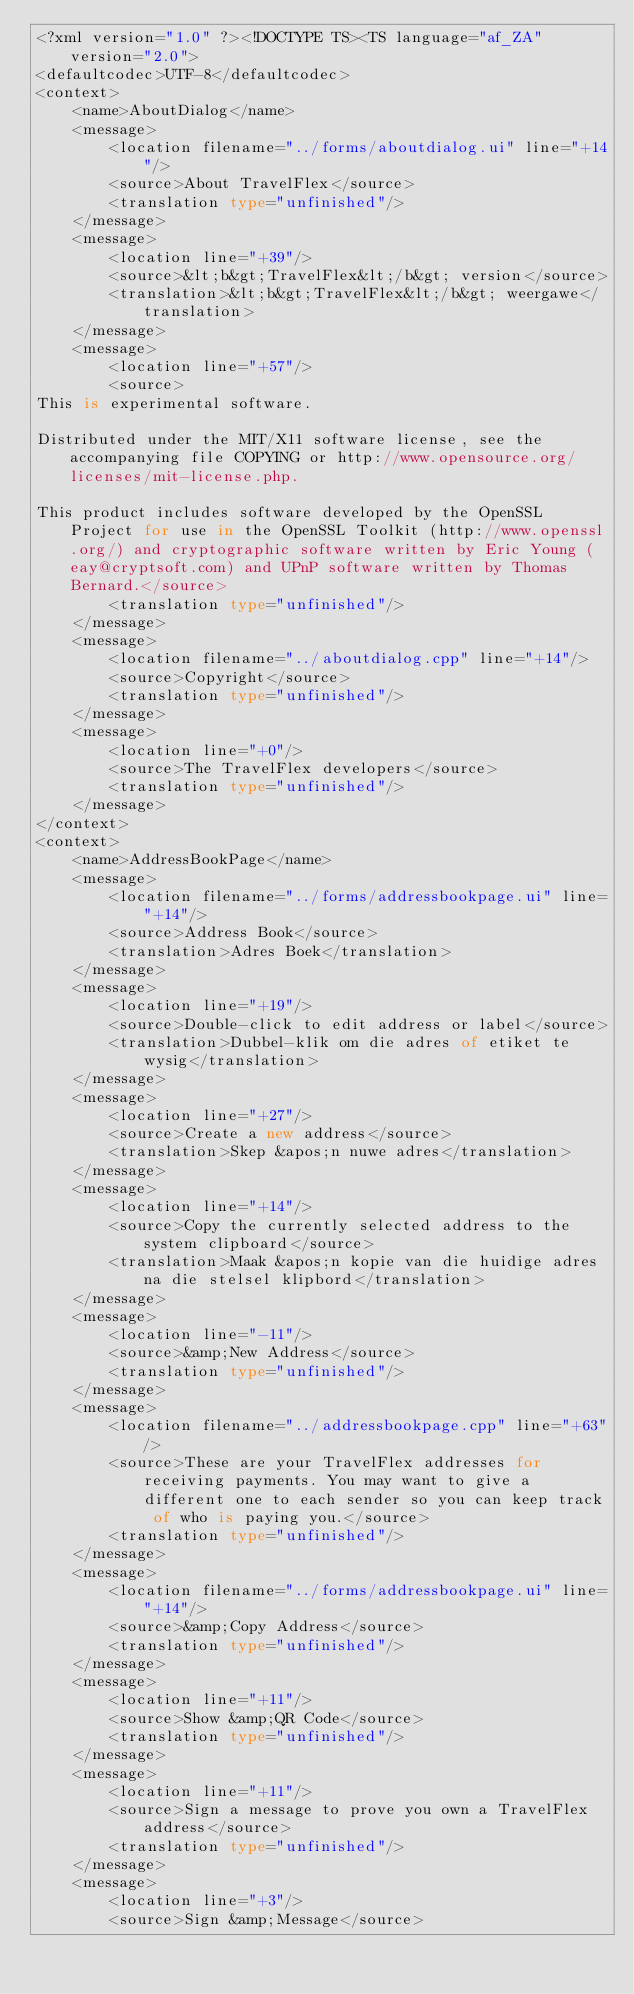<code> <loc_0><loc_0><loc_500><loc_500><_TypeScript_><?xml version="1.0" ?><!DOCTYPE TS><TS language="af_ZA" version="2.0">
<defaultcodec>UTF-8</defaultcodec>
<context>
    <name>AboutDialog</name>
    <message>
        <location filename="../forms/aboutdialog.ui" line="+14"/>
        <source>About TravelFlex</source>
        <translation type="unfinished"/>
    </message>
    <message>
        <location line="+39"/>
        <source>&lt;b&gt;TravelFlex&lt;/b&gt; version</source>
        <translation>&lt;b&gt;TravelFlex&lt;/b&gt; weergawe</translation>
    </message>
    <message>
        <location line="+57"/>
        <source>
This is experimental software.

Distributed under the MIT/X11 software license, see the accompanying file COPYING or http://www.opensource.org/licenses/mit-license.php.

This product includes software developed by the OpenSSL Project for use in the OpenSSL Toolkit (http://www.openssl.org/) and cryptographic software written by Eric Young (eay@cryptsoft.com) and UPnP software written by Thomas Bernard.</source>
        <translation type="unfinished"/>
    </message>
    <message>
        <location filename="../aboutdialog.cpp" line="+14"/>
        <source>Copyright</source>
        <translation type="unfinished"/>
    </message>
    <message>
        <location line="+0"/>
        <source>The TravelFlex developers</source>
        <translation type="unfinished"/>
    </message>
</context>
<context>
    <name>AddressBookPage</name>
    <message>
        <location filename="../forms/addressbookpage.ui" line="+14"/>
        <source>Address Book</source>
        <translation>Adres Boek</translation>
    </message>
    <message>
        <location line="+19"/>
        <source>Double-click to edit address or label</source>
        <translation>Dubbel-klik om die adres of etiket te wysig</translation>
    </message>
    <message>
        <location line="+27"/>
        <source>Create a new address</source>
        <translation>Skep &apos;n nuwe adres</translation>
    </message>
    <message>
        <location line="+14"/>
        <source>Copy the currently selected address to the system clipboard</source>
        <translation>Maak &apos;n kopie van die huidige adres na die stelsel klipbord</translation>
    </message>
    <message>
        <location line="-11"/>
        <source>&amp;New Address</source>
        <translation type="unfinished"/>
    </message>
    <message>
        <location filename="../addressbookpage.cpp" line="+63"/>
        <source>These are your TravelFlex addresses for receiving payments. You may want to give a different one to each sender so you can keep track of who is paying you.</source>
        <translation type="unfinished"/>
    </message>
    <message>
        <location filename="../forms/addressbookpage.ui" line="+14"/>
        <source>&amp;Copy Address</source>
        <translation type="unfinished"/>
    </message>
    <message>
        <location line="+11"/>
        <source>Show &amp;QR Code</source>
        <translation type="unfinished"/>
    </message>
    <message>
        <location line="+11"/>
        <source>Sign a message to prove you own a TravelFlex address</source>
        <translation type="unfinished"/>
    </message>
    <message>
        <location line="+3"/>
        <source>Sign &amp;Message</source></code> 